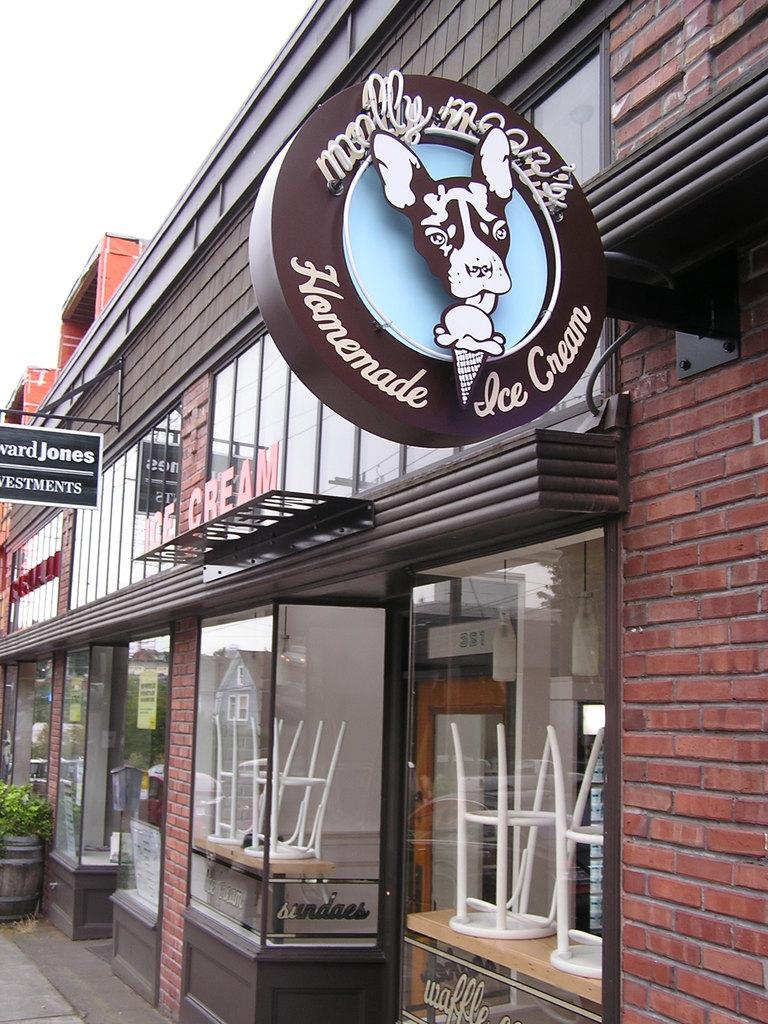What type of structure is visible in the image? There is a building in the image. What type of seating is present in the image? There are stools in the image. What type of signage is present in the image? There are name boards in the image. What is the plant placed in on the floor? There is a barrel on the floor with a plant in it. Can you describe any other objects in the image? There are some unspecified objects in the image. What type of amusement can be seen in the image? There is no amusement present in the image; it features a building, stools, name boards, a barrel with a plant, and unspecified objects. Where is the mailbox located in the image? There is no mailbox present in the image. 